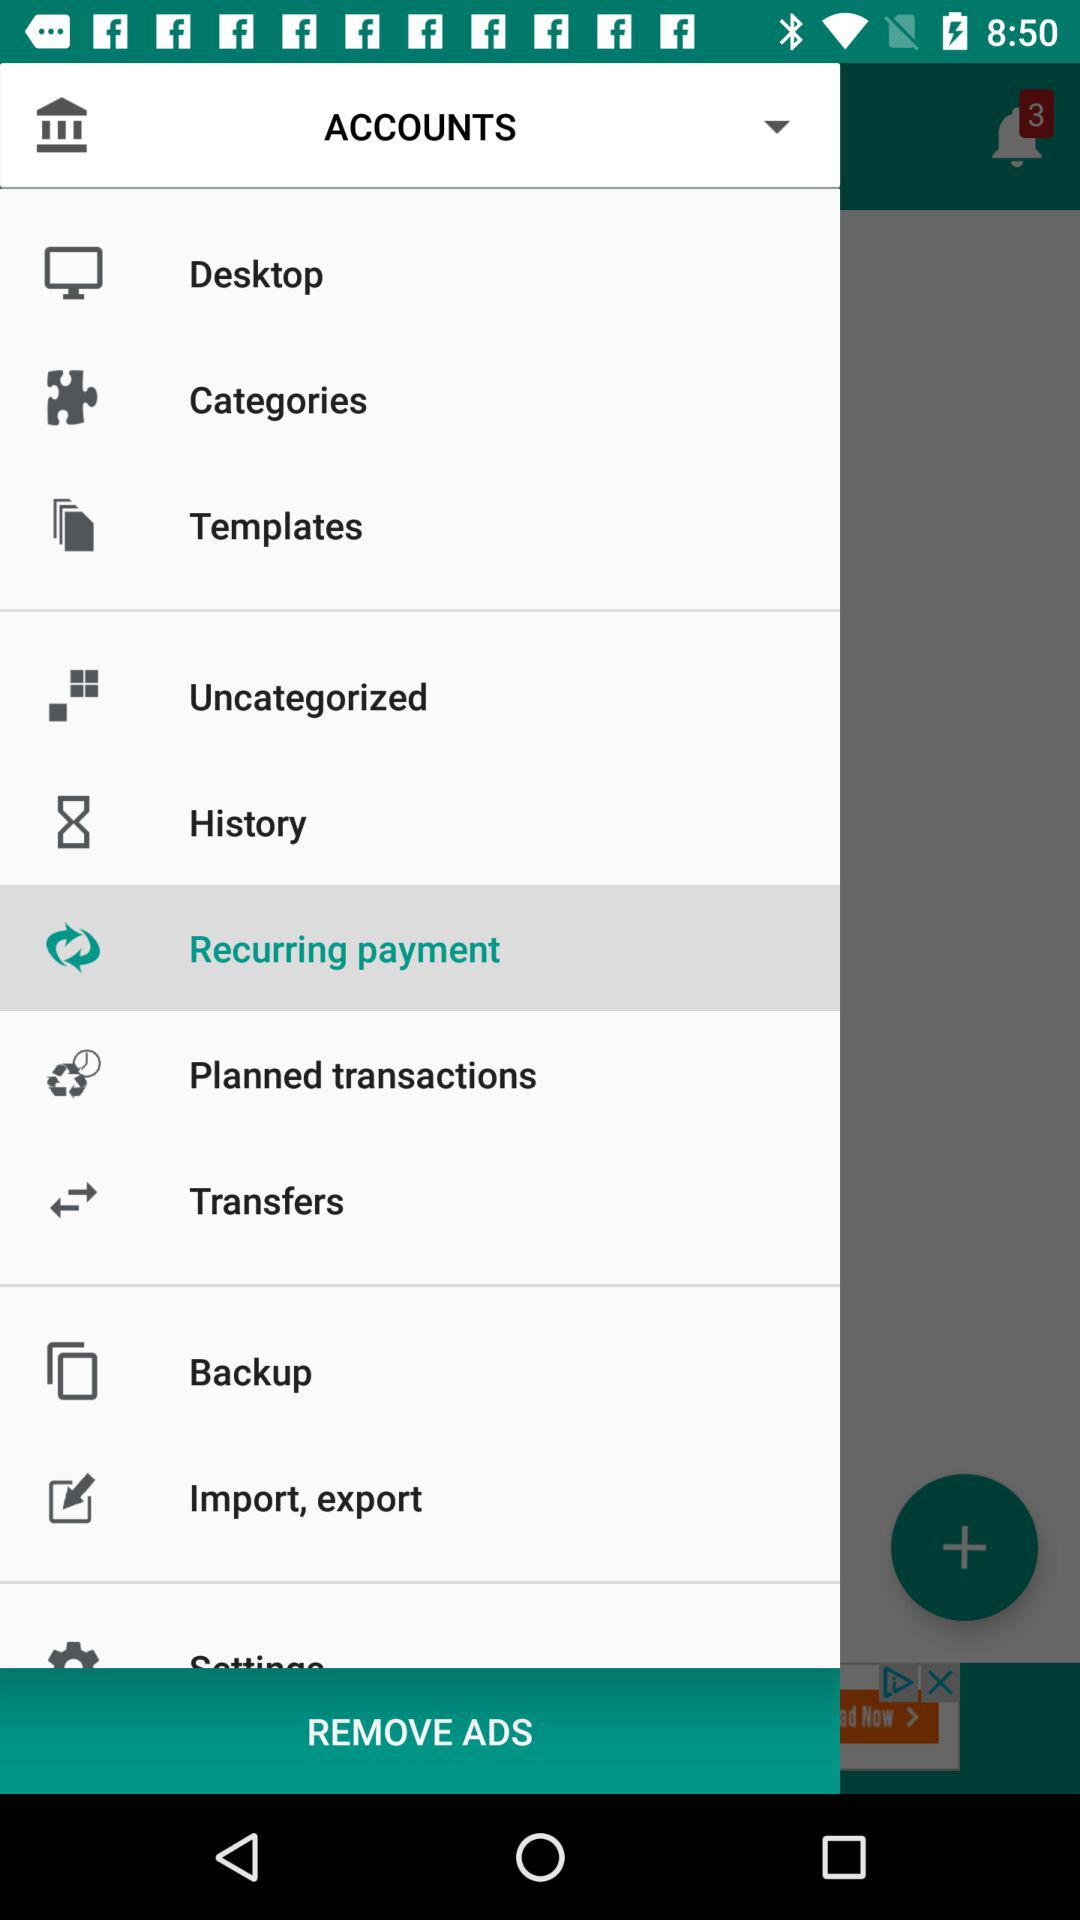Which option is selected? The selected option is "Recurring payment". 